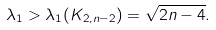Convert formula to latex. <formula><loc_0><loc_0><loc_500><loc_500>\lambda _ { 1 } > \lambda _ { 1 } ( K _ { 2 , n - 2 } ) = \sqrt { 2 n - 4 } .</formula> 